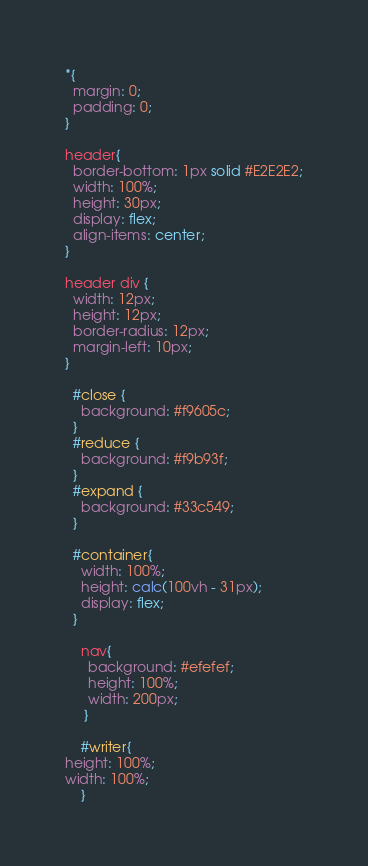Convert code to text. <code><loc_0><loc_0><loc_500><loc_500><_CSS_>*{
  margin: 0;
  padding: 0;
}

header{
  border-bottom: 1px solid #E2E2E2;
  width: 100%;
  height: 30px;
  display: flex;
  align-items: center;
}

header div {
  width: 12px;
  height: 12px;
  border-radius: 12px;
  margin-left: 10px;
}

  #close {
    background: #f9605c;
  }
  #reduce {
    background: #f9b93f;
  }
  #expand {
    background: #33c549;
  }

  #container{
    width: 100%;
    height: calc(100vh - 31px);
    display: flex;
  }

    nav{
      background: #efefef;
      height: 100%;
      width: 200px;
     }

    #writer{
height: 100%;
width: 100%;
    }
</code> 